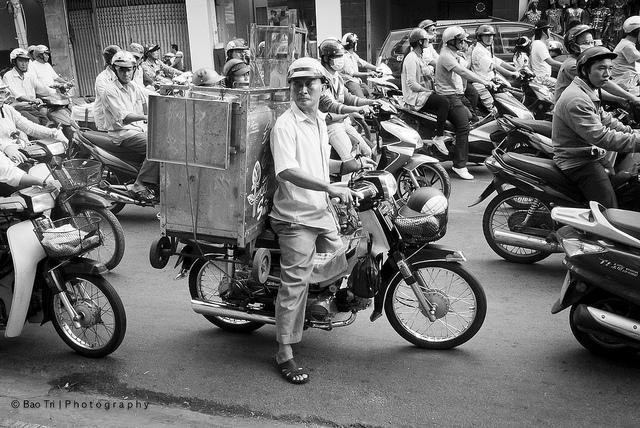How many people are wearing helmets?
Write a very short answer. All. Are these people wearing helmets?
Give a very brief answer. Yes. Where is the man who is wearing a sandal?
Give a very brief answer. Center. Do most motorcycles have one rider?
Concise answer only. Yes. Who is riding the bikes?
Keep it brief. Men. 